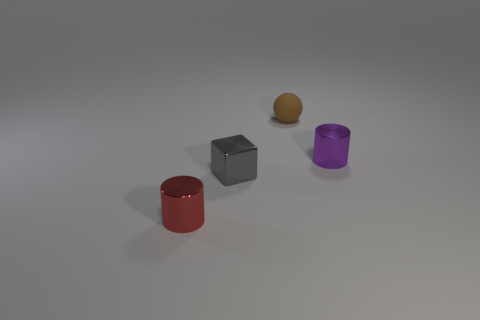Add 1 yellow balls. How many objects exist? 5 Subtract all cubes. How many objects are left? 3 Subtract all tiny rubber objects. Subtract all brown matte balls. How many objects are left? 2 Add 4 shiny blocks. How many shiny blocks are left? 5 Add 4 tiny green cubes. How many tiny green cubes exist? 4 Subtract 0 gray cylinders. How many objects are left? 4 